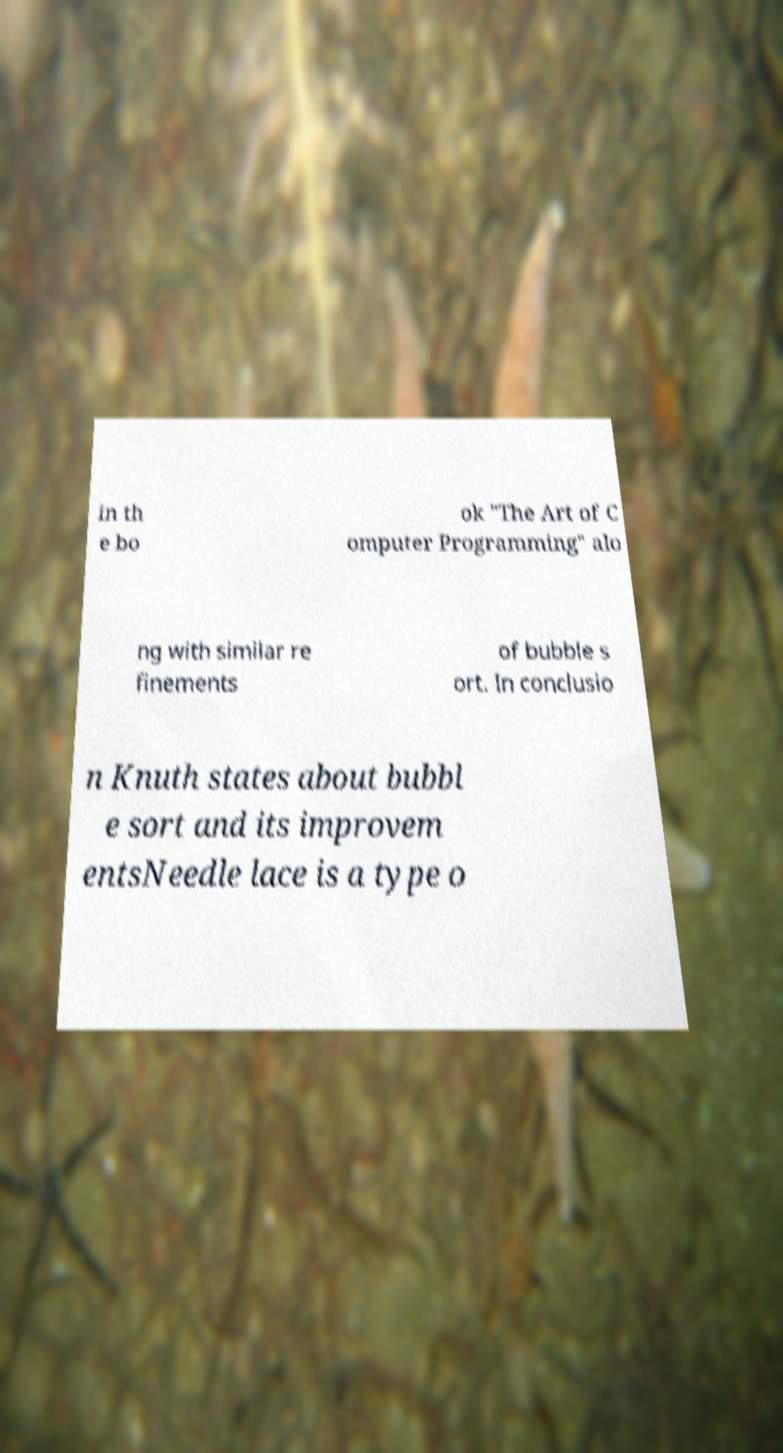What messages or text are displayed in this image? I need them in a readable, typed format. in th e bo ok "The Art of C omputer Programming" alo ng with similar re finements of bubble s ort. In conclusio n Knuth states about bubbl e sort and its improvem entsNeedle lace is a type o 